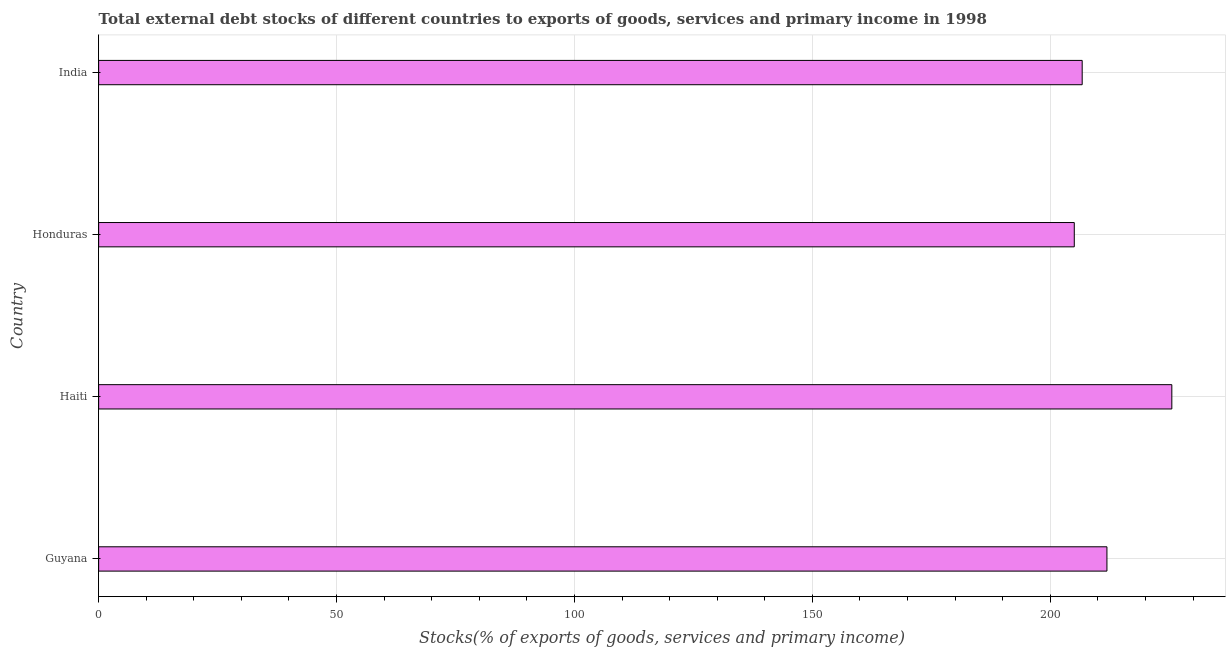Does the graph contain any zero values?
Make the answer very short. No. Does the graph contain grids?
Give a very brief answer. Yes. What is the title of the graph?
Provide a short and direct response. Total external debt stocks of different countries to exports of goods, services and primary income in 1998. What is the label or title of the X-axis?
Keep it short and to the point. Stocks(% of exports of goods, services and primary income). What is the external debt stocks in Haiti?
Your answer should be very brief. 225.54. Across all countries, what is the maximum external debt stocks?
Your answer should be very brief. 225.54. Across all countries, what is the minimum external debt stocks?
Make the answer very short. 205.04. In which country was the external debt stocks maximum?
Provide a succinct answer. Haiti. In which country was the external debt stocks minimum?
Offer a very short reply. Honduras. What is the sum of the external debt stocks?
Offer a very short reply. 849.18. What is the difference between the external debt stocks in Haiti and India?
Ensure brevity in your answer.  18.84. What is the average external debt stocks per country?
Give a very brief answer. 212.29. What is the median external debt stocks?
Give a very brief answer. 209.3. What is the ratio of the external debt stocks in Guyana to that in India?
Keep it short and to the point. 1.02. Is the external debt stocks in Haiti less than that in Honduras?
Offer a very short reply. No. Is the difference between the external debt stocks in Haiti and India greater than the difference between any two countries?
Your answer should be very brief. No. What is the difference between the highest and the second highest external debt stocks?
Keep it short and to the point. 13.64. In how many countries, is the external debt stocks greater than the average external debt stocks taken over all countries?
Offer a terse response. 1. Are all the bars in the graph horizontal?
Your answer should be very brief. Yes. What is the Stocks(% of exports of goods, services and primary income) in Guyana?
Your answer should be very brief. 211.9. What is the Stocks(% of exports of goods, services and primary income) in Haiti?
Make the answer very short. 225.54. What is the Stocks(% of exports of goods, services and primary income) in Honduras?
Offer a very short reply. 205.04. What is the Stocks(% of exports of goods, services and primary income) in India?
Your answer should be compact. 206.7. What is the difference between the Stocks(% of exports of goods, services and primary income) in Guyana and Haiti?
Keep it short and to the point. -13.64. What is the difference between the Stocks(% of exports of goods, services and primary income) in Guyana and Honduras?
Offer a very short reply. 6.86. What is the difference between the Stocks(% of exports of goods, services and primary income) in Guyana and India?
Your answer should be very brief. 5.2. What is the difference between the Stocks(% of exports of goods, services and primary income) in Haiti and Honduras?
Offer a very short reply. 20.5. What is the difference between the Stocks(% of exports of goods, services and primary income) in Haiti and India?
Make the answer very short. 18.84. What is the difference between the Stocks(% of exports of goods, services and primary income) in Honduras and India?
Offer a very short reply. -1.66. What is the ratio of the Stocks(% of exports of goods, services and primary income) in Guyana to that in Honduras?
Offer a very short reply. 1.03. What is the ratio of the Stocks(% of exports of goods, services and primary income) in Haiti to that in Honduras?
Offer a terse response. 1.1. What is the ratio of the Stocks(% of exports of goods, services and primary income) in Haiti to that in India?
Provide a succinct answer. 1.09. 